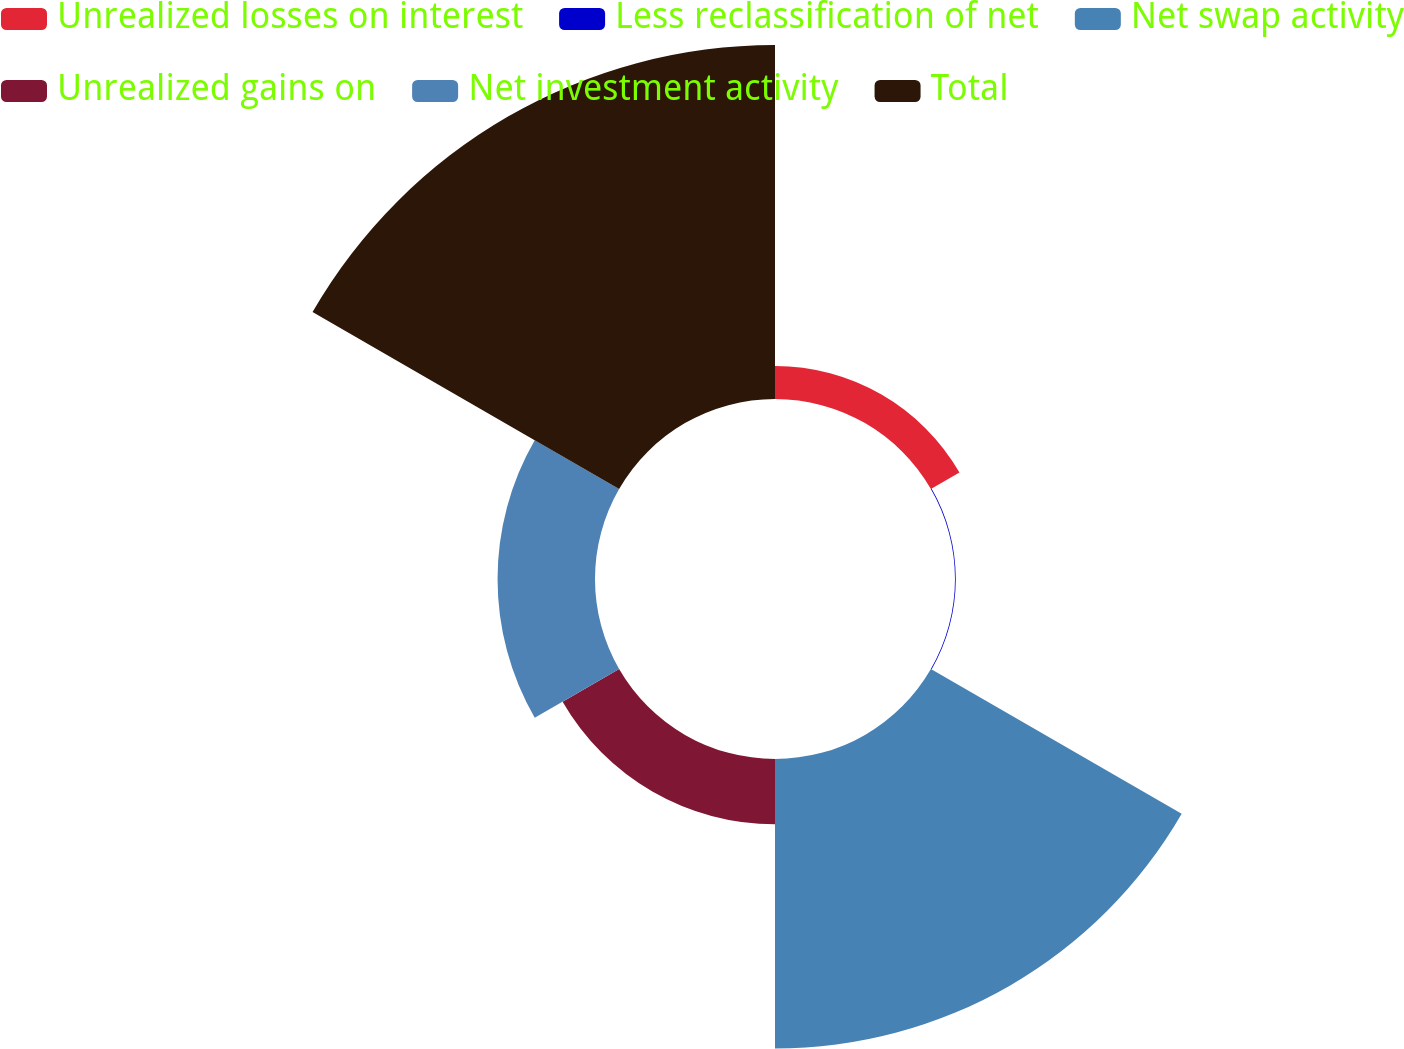<chart> <loc_0><loc_0><loc_500><loc_500><pie_chart><fcel>Unrealized losses on interest<fcel>Less reclassification of net<fcel>Net swap activity<fcel>Unrealized gains on<fcel>Net investment activity<fcel>Total<nl><fcel>3.93%<fcel>0.09%<fcel>34.47%<fcel>7.77%<fcel>11.6%<fcel>42.14%<nl></chart> 